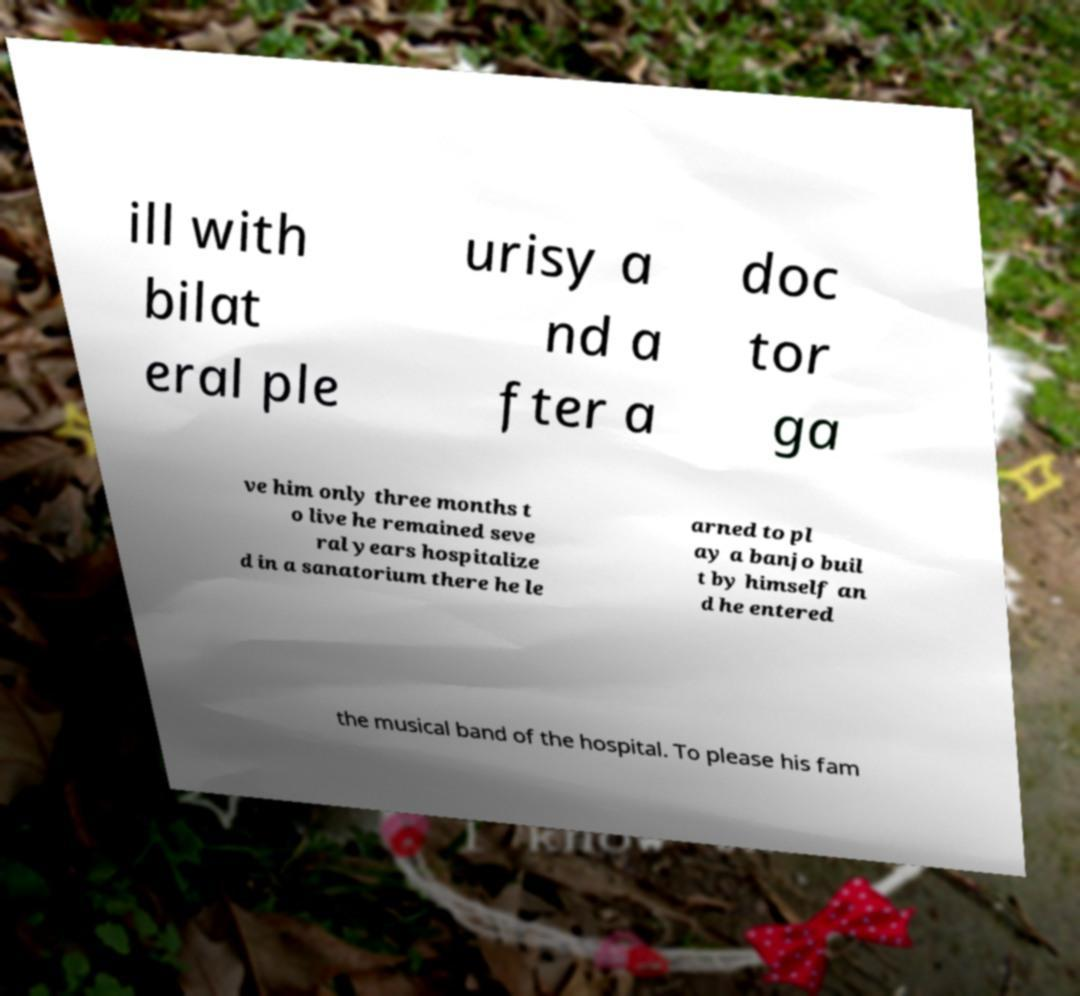Please read and relay the text visible in this image. What does it say? ill with bilat eral ple urisy a nd a fter a doc tor ga ve him only three months t o live he remained seve ral years hospitalize d in a sanatorium there he le arned to pl ay a banjo buil t by himself an d he entered the musical band of the hospital. To please his fam 